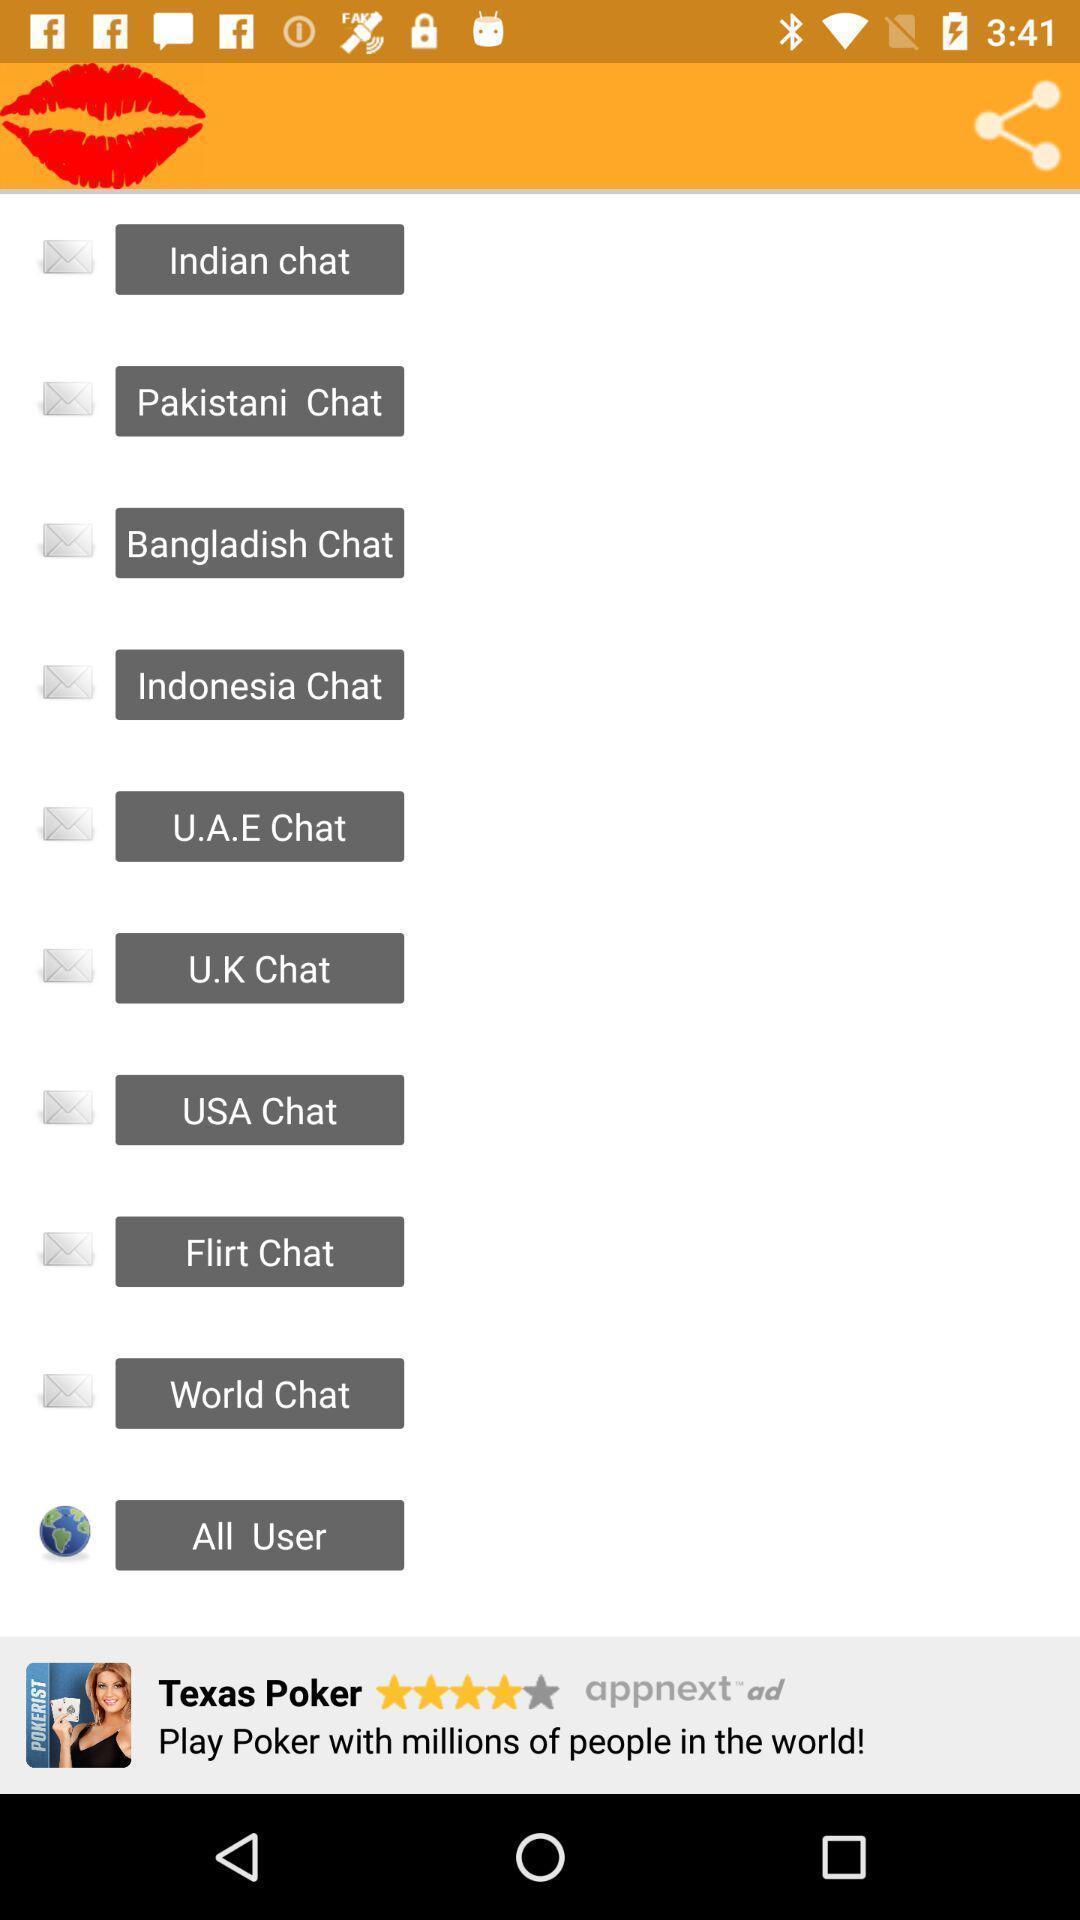Tell me what you see in this picture. Screen shows list of various chats. 